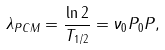<formula> <loc_0><loc_0><loc_500><loc_500>\lambda _ { P C M } = \frac { \ln 2 } { T _ { 1 / 2 } } = \nu _ { 0 } P _ { 0 } P ,</formula> 